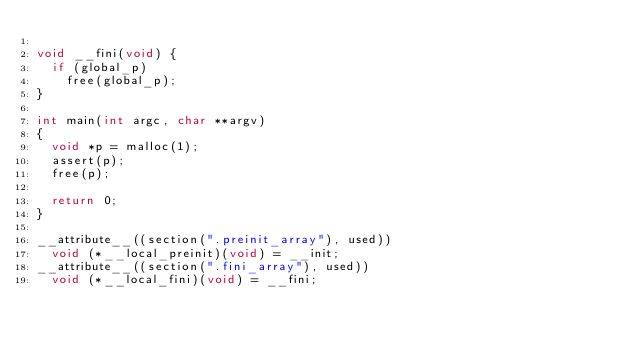<code> <loc_0><loc_0><loc_500><loc_500><_C_>
void __fini(void) {
  if (global_p)
    free(global_p);
}

int main(int argc, char **argv)
{
  void *p = malloc(1);
  assert(p);
  free(p);

  return 0;
}

__attribute__((section(".preinit_array"), used))
  void (*__local_preinit)(void) = __init;
__attribute__((section(".fini_array"), used))
  void (*__local_fini)(void) = __fini;
</code> 